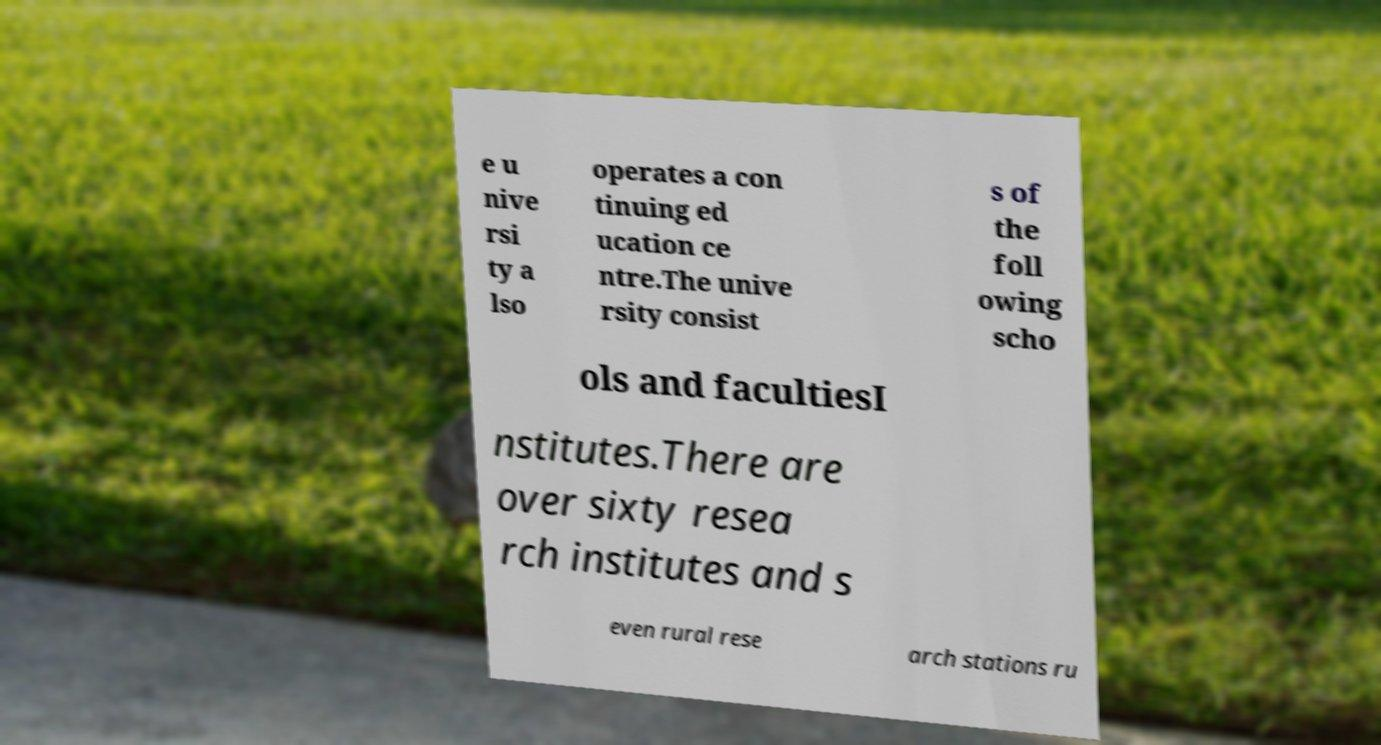Can you read and provide the text displayed in the image?This photo seems to have some interesting text. Can you extract and type it out for me? e u nive rsi ty a lso operates a con tinuing ed ucation ce ntre.The unive rsity consist s of the foll owing scho ols and facultiesI nstitutes.There are over sixty resea rch institutes and s even rural rese arch stations ru 